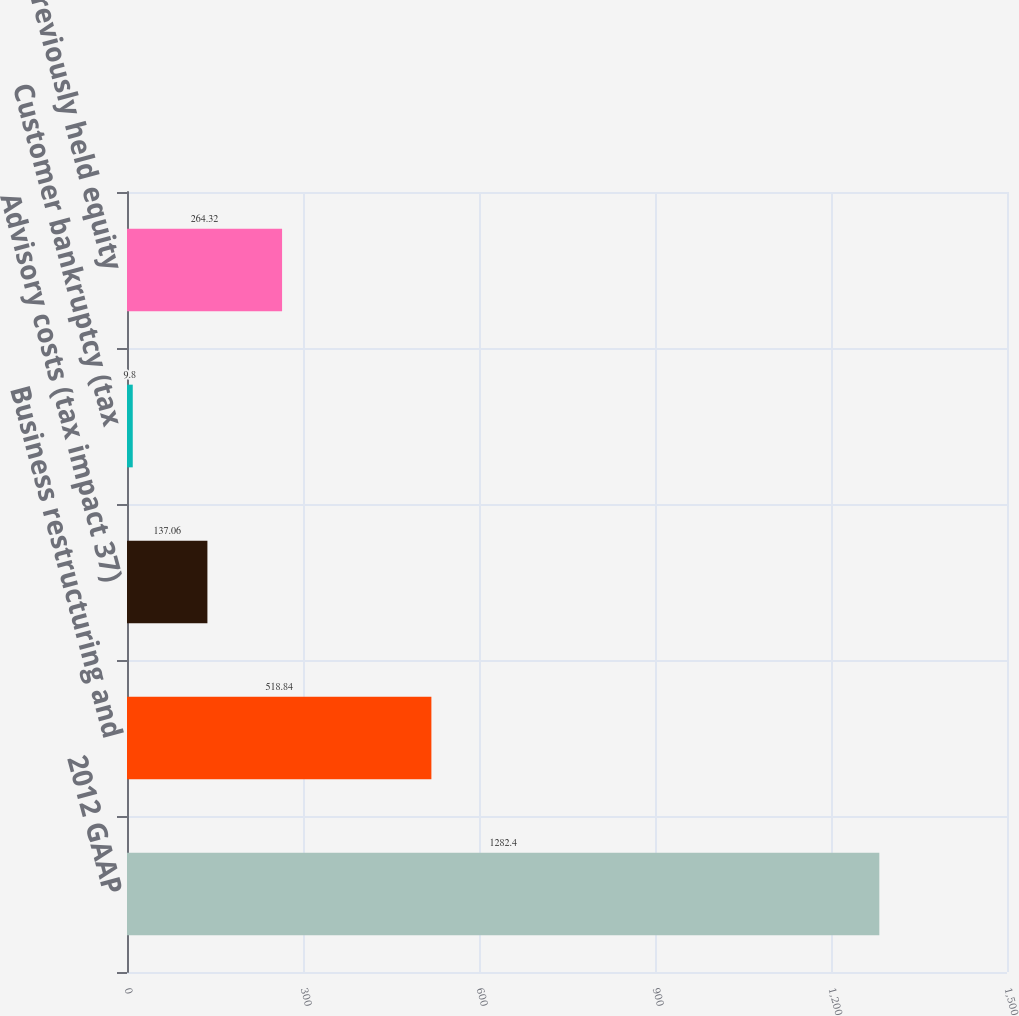Convert chart to OTSL. <chart><loc_0><loc_0><loc_500><loc_500><bar_chart><fcel>2012 GAAP<fcel>Business restructuring and<fcel>Advisory costs (tax impact 37)<fcel>Customer bankruptcy (tax<fcel>Gain on previously held equity<nl><fcel>1282.4<fcel>518.84<fcel>137.06<fcel>9.8<fcel>264.32<nl></chart> 